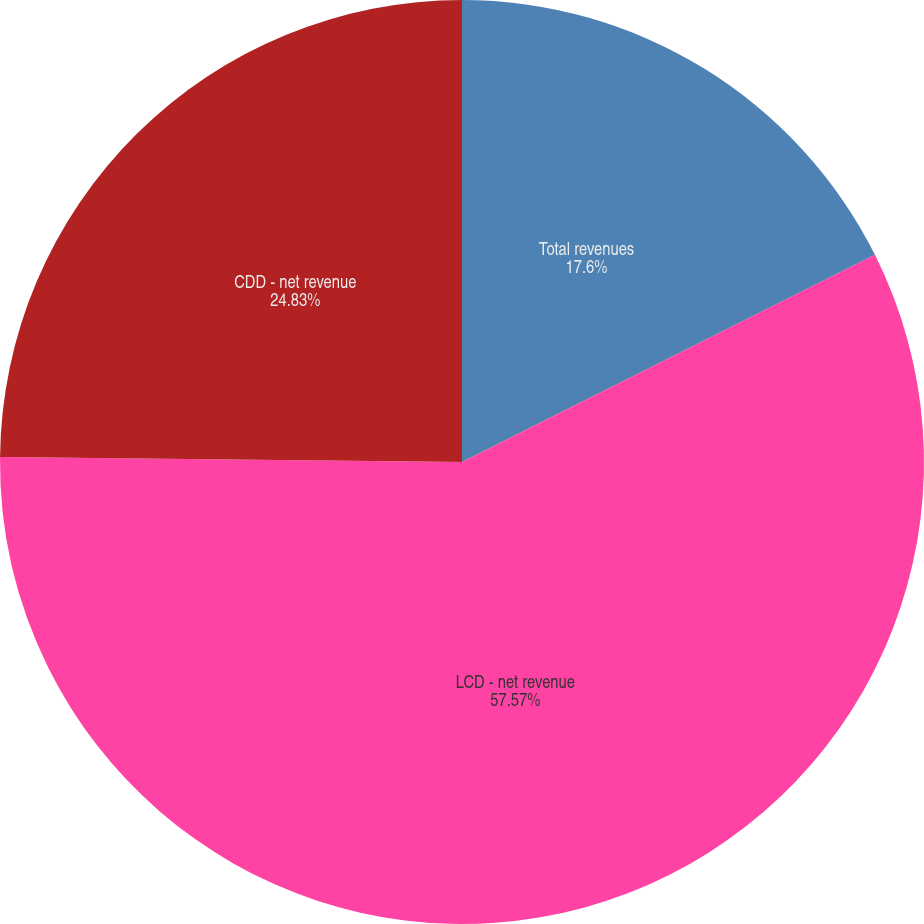<chart> <loc_0><loc_0><loc_500><loc_500><pie_chart><fcel>Total revenues<fcel>LCD - net revenue<fcel>CDD - net revenue<nl><fcel>17.6%<fcel>57.57%<fcel>24.83%<nl></chart> 